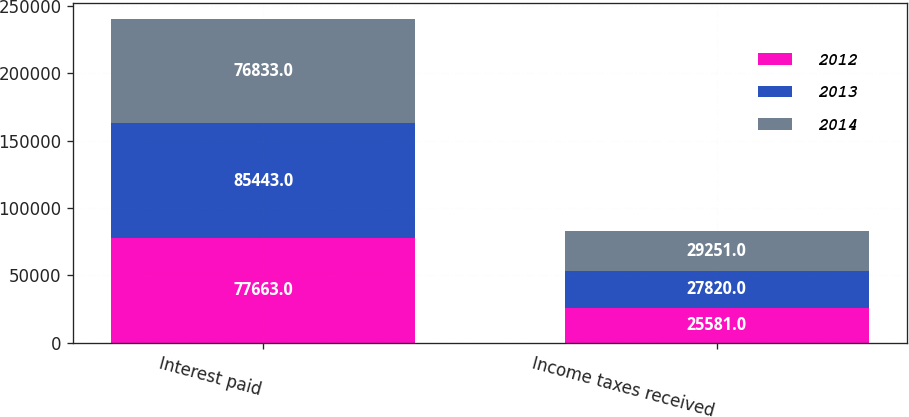Convert chart. <chart><loc_0><loc_0><loc_500><loc_500><stacked_bar_chart><ecel><fcel>Interest paid<fcel>Income taxes received<nl><fcel>2012<fcel>77663<fcel>25581<nl><fcel>2013<fcel>85443<fcel>27820<nl><fcel>2014<fcel>76833<fcel>29251<nl></chart> 